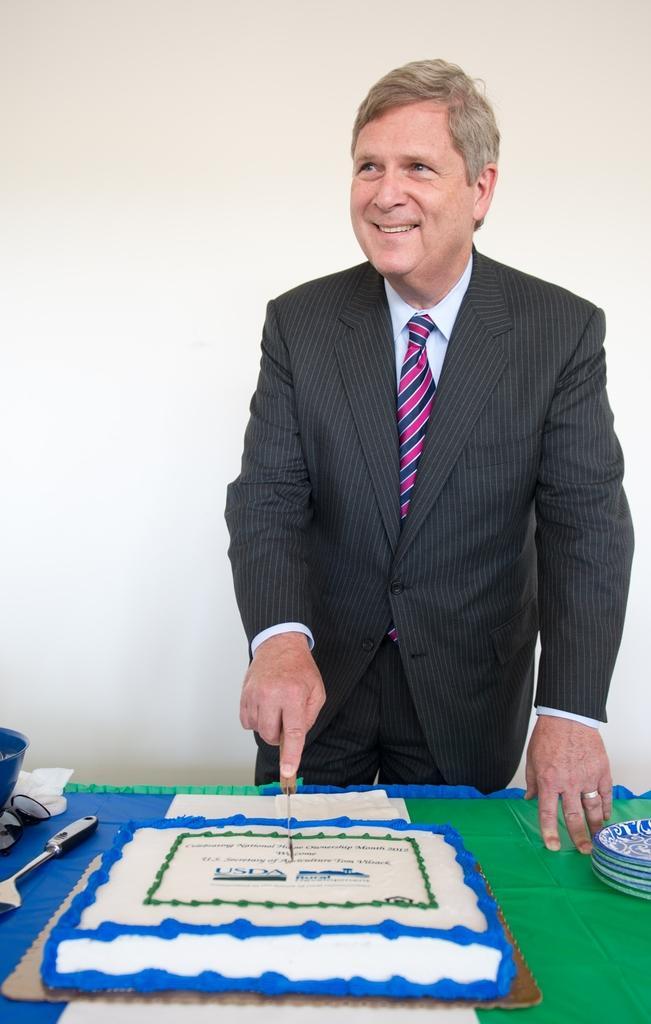Could you give a brief overview of what you see in this image? In this image we can see a person standing and cutting the cake on the table. On the table there are goggles, plates and a ladle. 